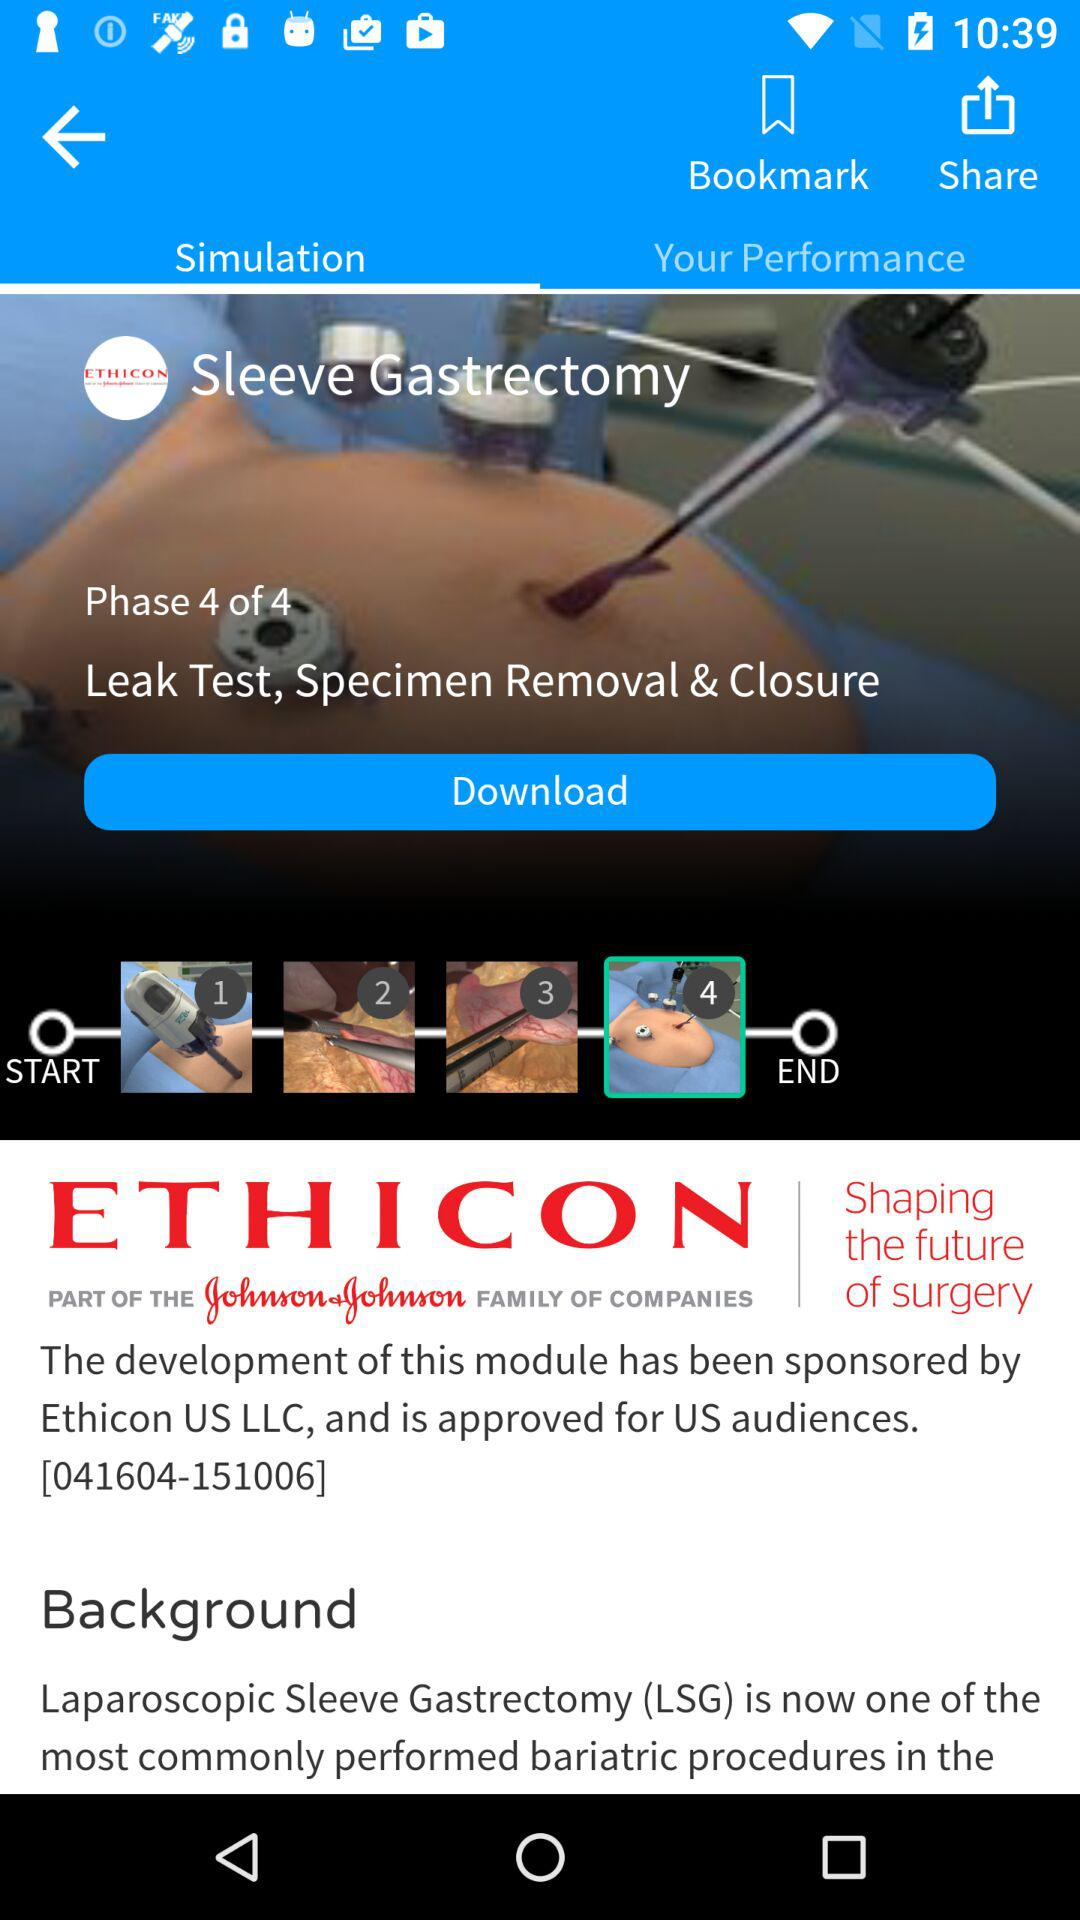Which tab am I on? You are on the "Simulation" tab. 